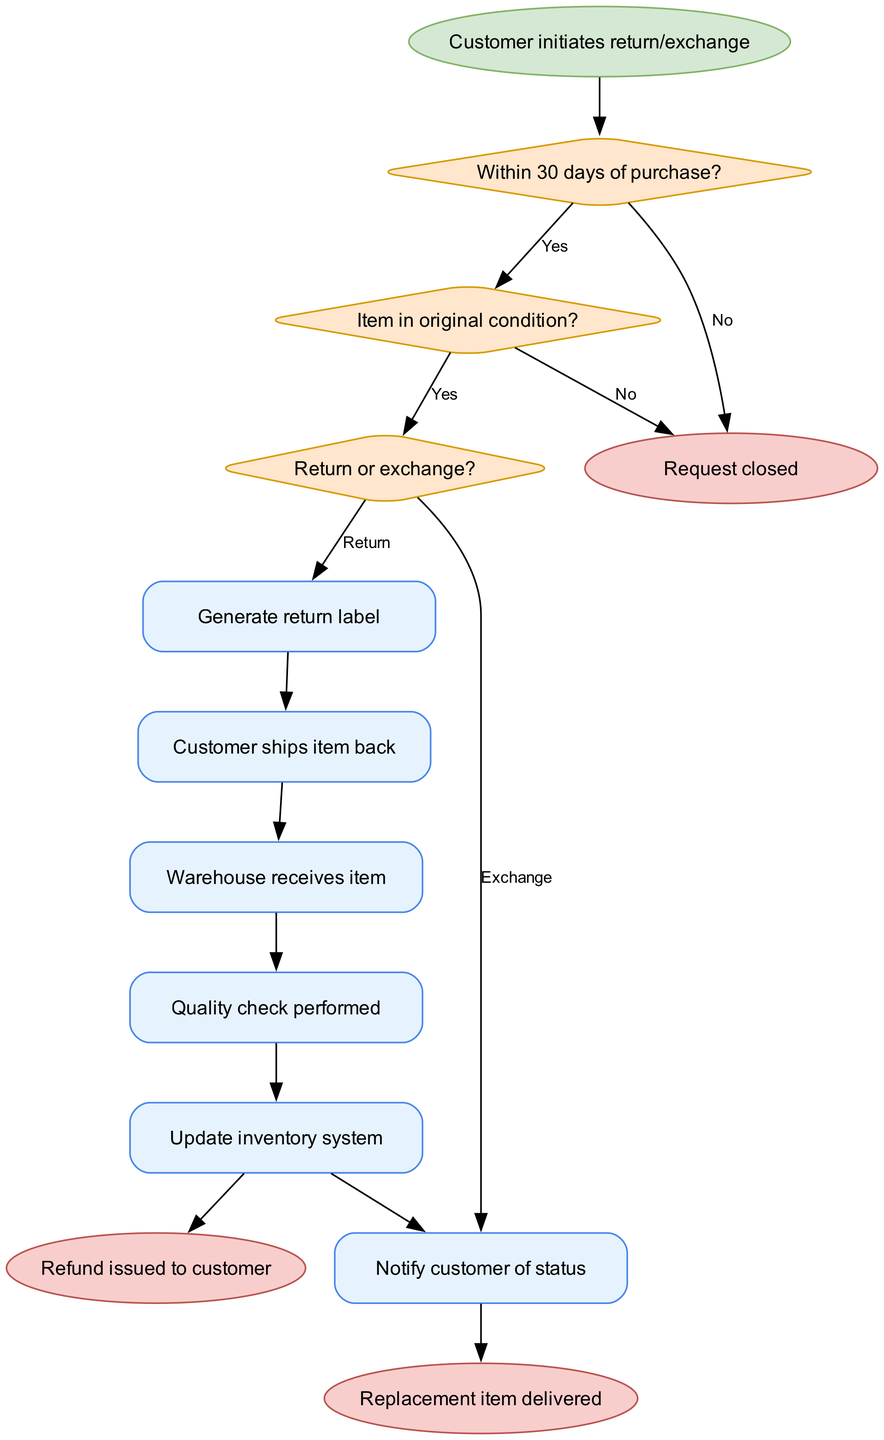What is the starting point of the flowchart? The starting point of the flowchart is clearly indicated as "Customer initiates return/exchange," which is represented as the first node connected to the decision-making process.
Answer: Customer initiates return/exchange How many decision nodes are present in the flowchart? The flowchart contains three decision nodes based on the conditions outlined in the diagram for processing returns/exchanges: "Within 30 days of purchase?", "Item in original condition?", and "Return or exchange?"
Answer: 3 What happens if the item is not in original condition? If the item is not in original condition, the flowchart directs to "Reject return/exchange," which leads to the end of the process indicating the request is denied.
Answer: Reject return/exchange What actions follow after "Approve return/exchange"? After "Approve return/exchange," the process will be guided by the decision node, where the user has to specify if they want to return or exchange the item, which leads to either processing a refund or shipping a replacement item.
Answer: Return or exchange What is the final step in the process if a refund is issued? The final step in the process, if a refund is issued, is depicted as "Refund issued to customer," indicating the completion of the return procedure.
Answer: Refund issued to customer What is the output if the request is denied? If the request is denied, the flowchart indicates an end point where no further action is taken, leading directly to "Request closed," as the return/exchange is not approved.
Answer: Request closed What icons are used for the processes in the flowchart? The processes in the flowchart are represented with rectangular icons, suggesting actions like generating return labels, shipping items, and quality checks, which are visually distinct from the decision nodes.
Answer: Rectangular icons What does the flowchart indicate happens after the customer ships the item back? After the customer ships the item back, the next step in the flowchart indicates that "Warehouse receives item," denoting the beginning of the processing sequence for the return or exchange.
Answer: Warehouse receives item 